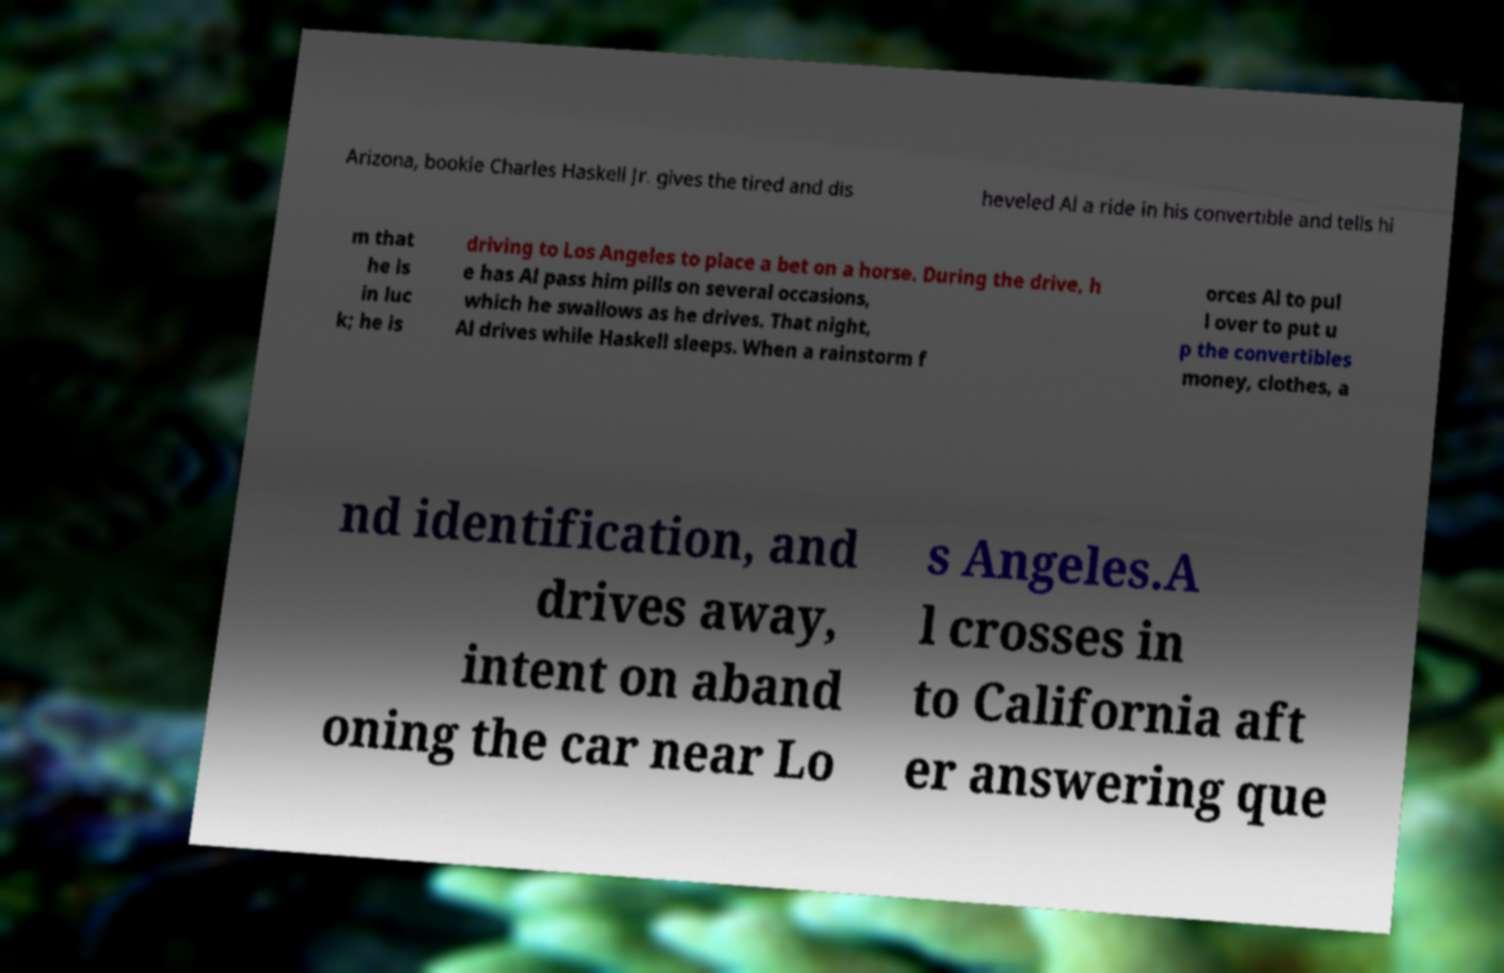I need the written content from this picture converted into text. Can you do that? Arizona, bookie Charles Haskell Jr. gives the tired and dis heveled Al a ride in his convertible and tells hi m that he is in luc k; he is driving to Los Angeles to place a bet on a horse. During the drive, h e has Al pass him pills on several occasions, which he swallows as he drives. That night, Al drives while Haskell sleeps. When a rainstorm f orces Al to pul l over to put u p the convertibles money, clothes, a nd identification, and drives away, intent on aband oning the car near Lo s Angeles.A l crosses in to California aft er answering que 